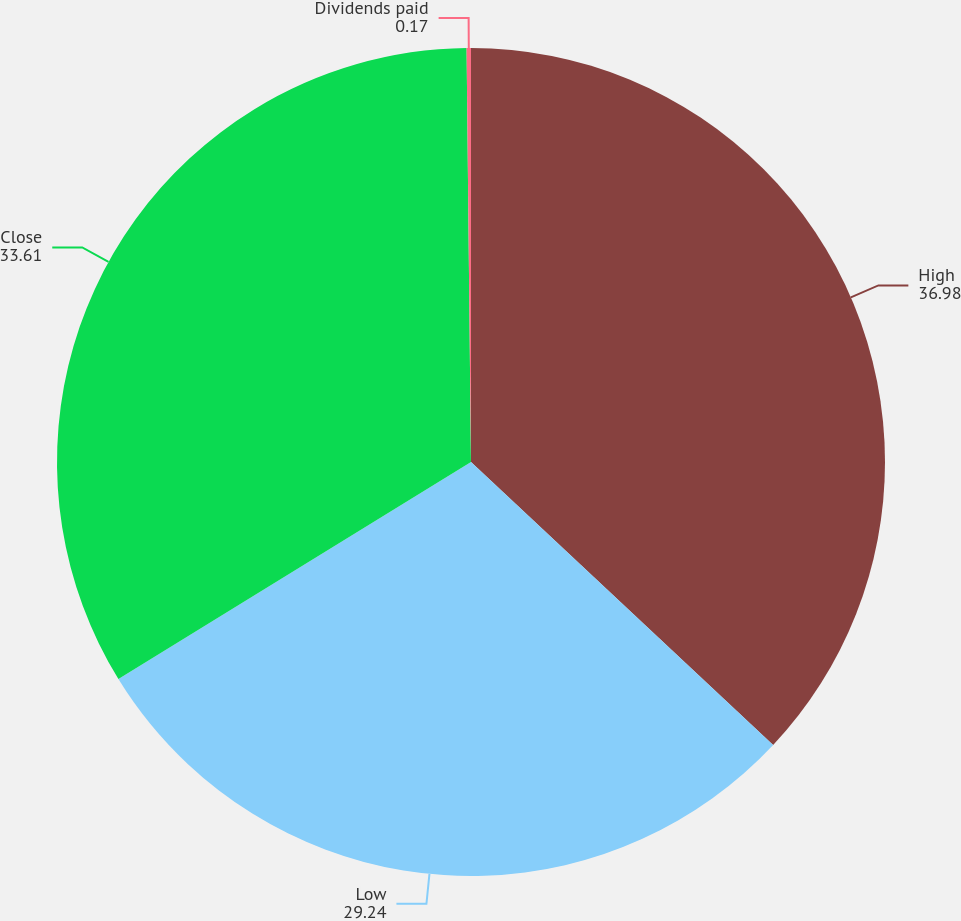<chart> <loc_0><loc_0><loc_500><loc_500><pie_chart><fcel>High<fcel>Low<fcel>Close<fcel>Dividends paid<nl><fcel>36.98%<fcel>29.24%<fcel>33.61%<fcel>0.17%<nl></chart> 